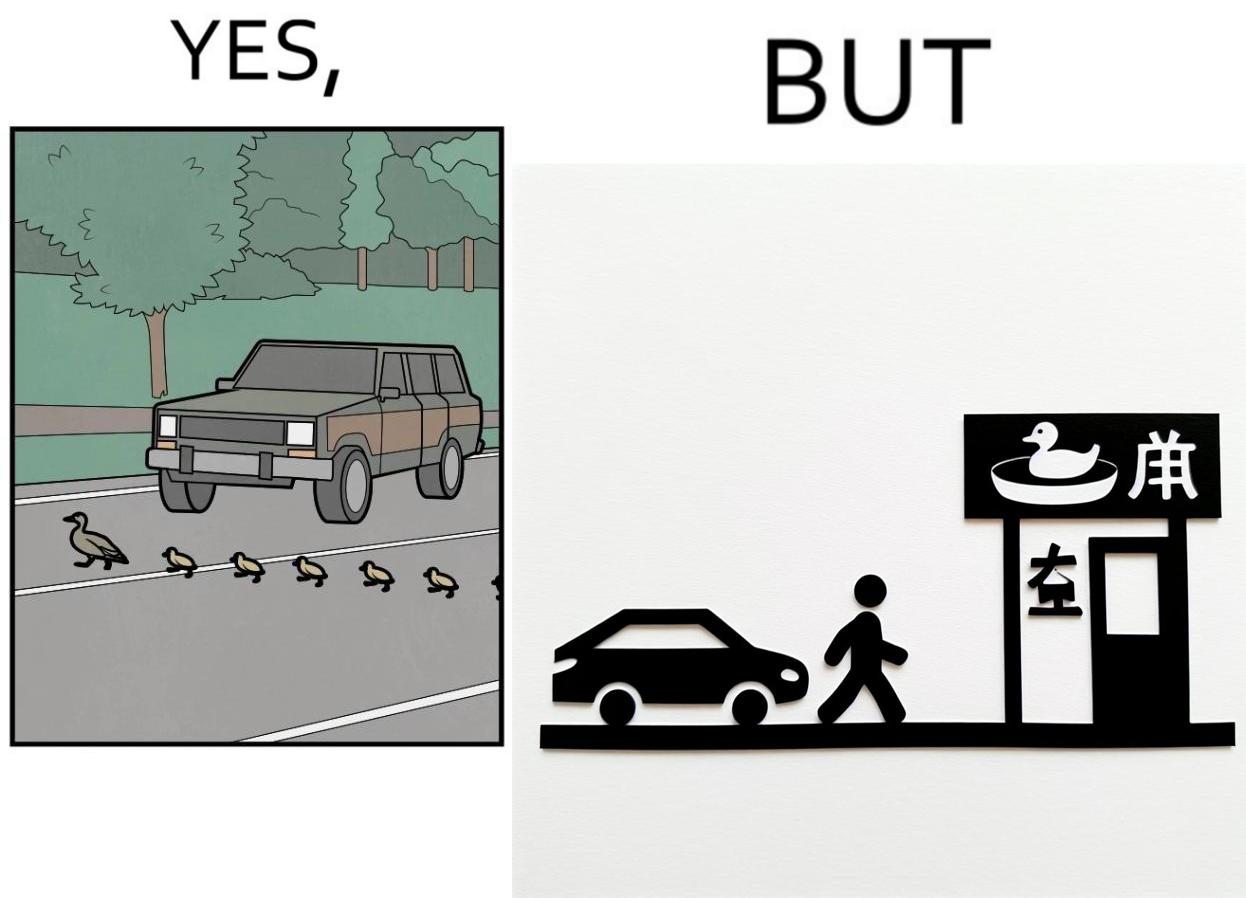Is there satirical content in this image? Yes, this image is satirical. 